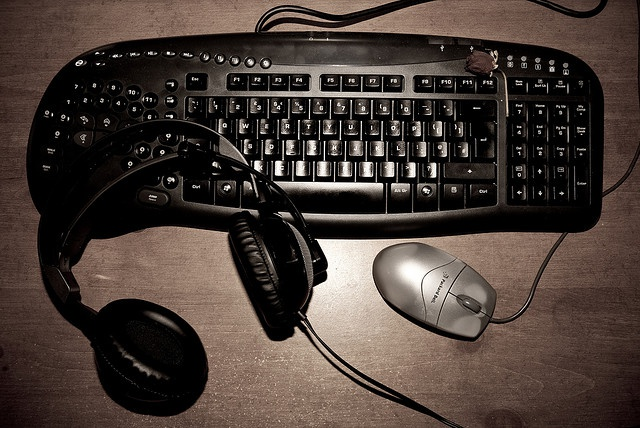Describe the objects in this image and their specific colors. I can see keyboard in black, gray, and darkgray tones and mouse in black, gray, darkgray, and white tones in this image. 